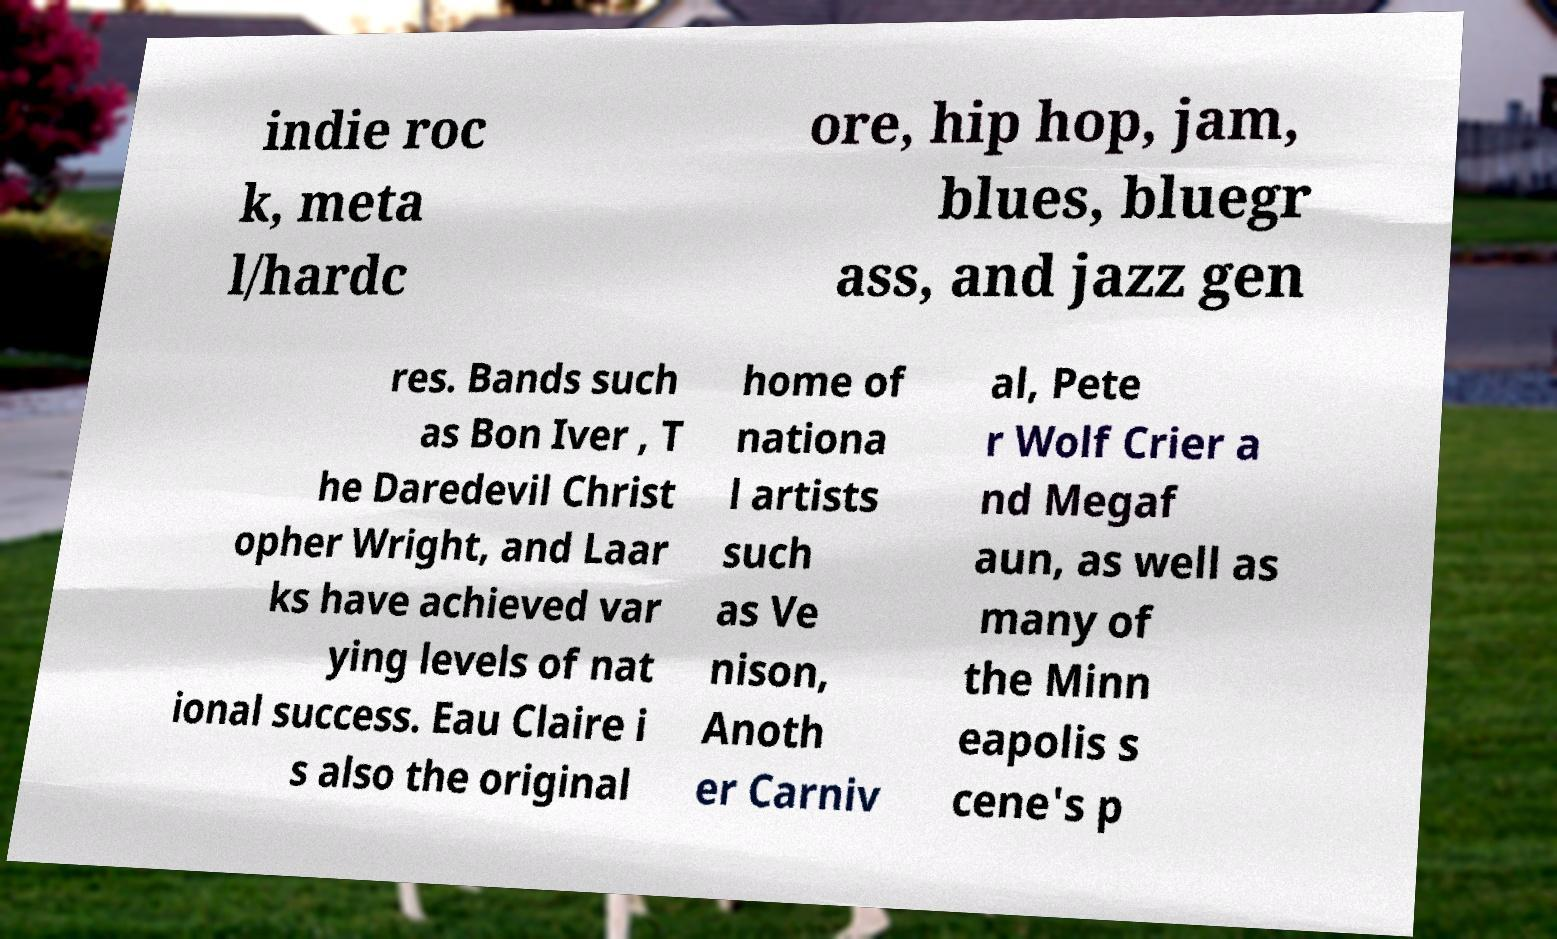There's text embedded in this image that I need extracted. Can you transcribe it verbatim? indie roc k, meta l/hardc ore, hip hop, jam, blues, bluegr ass, and jazz gen res. Bands such as Bon Iver , T he Daredevil Christ opher Wright, and Laar ks have achieved var ying levels of nat ional success. Eau Claire i s also the original home of nationa l artists such as Ve nison, Anoth er Carniv al, Pete r Wolf Crier a nd Megaf aun, as well as many of the Minn eapolis s cene's p 